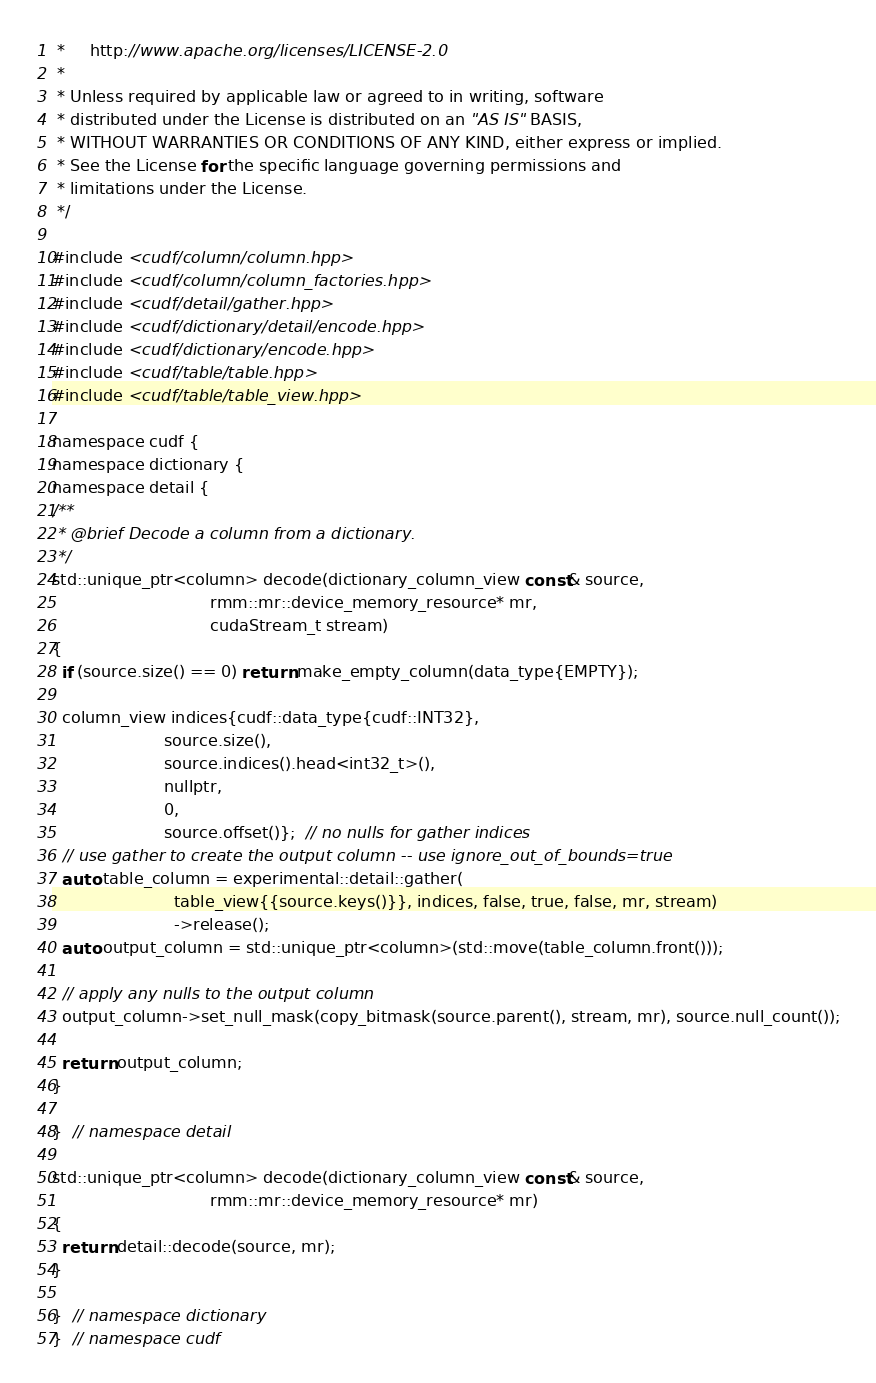<code> <loc_0><loc_0><loc_500><loc_500><_Cuda_> *     http://www.apache.org/licenses/LICENSE-2.0
 *
 * Unless required by applicable law or agreed to in writing, software
 * distributed under the License is distributed on an "AS IS" BASIS,
 * WITHOUT WARRANTIES OR CONDITIONS OF ANY KIND, either express or implied.
 * See the License for the specific language governing permissions and
 * limitations under the License.
 */

#include <cudf/column/column.hpp>
#include <cudf/column/column_factories.hpp>
#include <cudf/detail/gather.hpp>
#include <cudf/dictionary/detail/encode.hpp>
#include <cudf/dictionary/encode.hpp>
#include <cudf/table/table.hpp>
#include <cudf/table/table_view.hpp>

namespace cudf {
namespace dictionary {
namespace detail {
/**
 * @brief Decode a column from a dictionary.
 */
std::unique_ptr<column> decode(dictionary_column_view const& source,
                               rmm::mr::device_memory_resource* mr,
                               cudaStream_t stream)
{
  if (source.size() == 0) return make_empty_column(data_type{EMPTY});

  column_view indices{cudf::data_type{cudf::INT32},
                      source.size(),
                      source.indices().head<int32_t>(),
                      nullptr,
                      0,
                      source.offset()};  // no nulls for gather indices
  // use gather to create the output column -- use ignore_out_of_bounds=true
  auto table_column = experimental::detail::gather(
                        table_view{{source.keys()}}, indices, false, true, false, mr, stream)
                        ->release();
  auto output_column = std::unique_ptr<column>(std::move(table_column.front()));

  // apply any nulls to the output column
  output_column->set_null_mask(copy_bitmask(source.parent(), stream, mr), source.null_count());

  return output_column;
}

}  // namespace detail

std::unique_ptr<column> decode(dictionary_column_view const& source,
                               rmm::mr::device_memory_resource* mr)
{
  return detail::decode(source, mr);
}

}  // namespace dictionary
}  // namespace cudf
</code> 